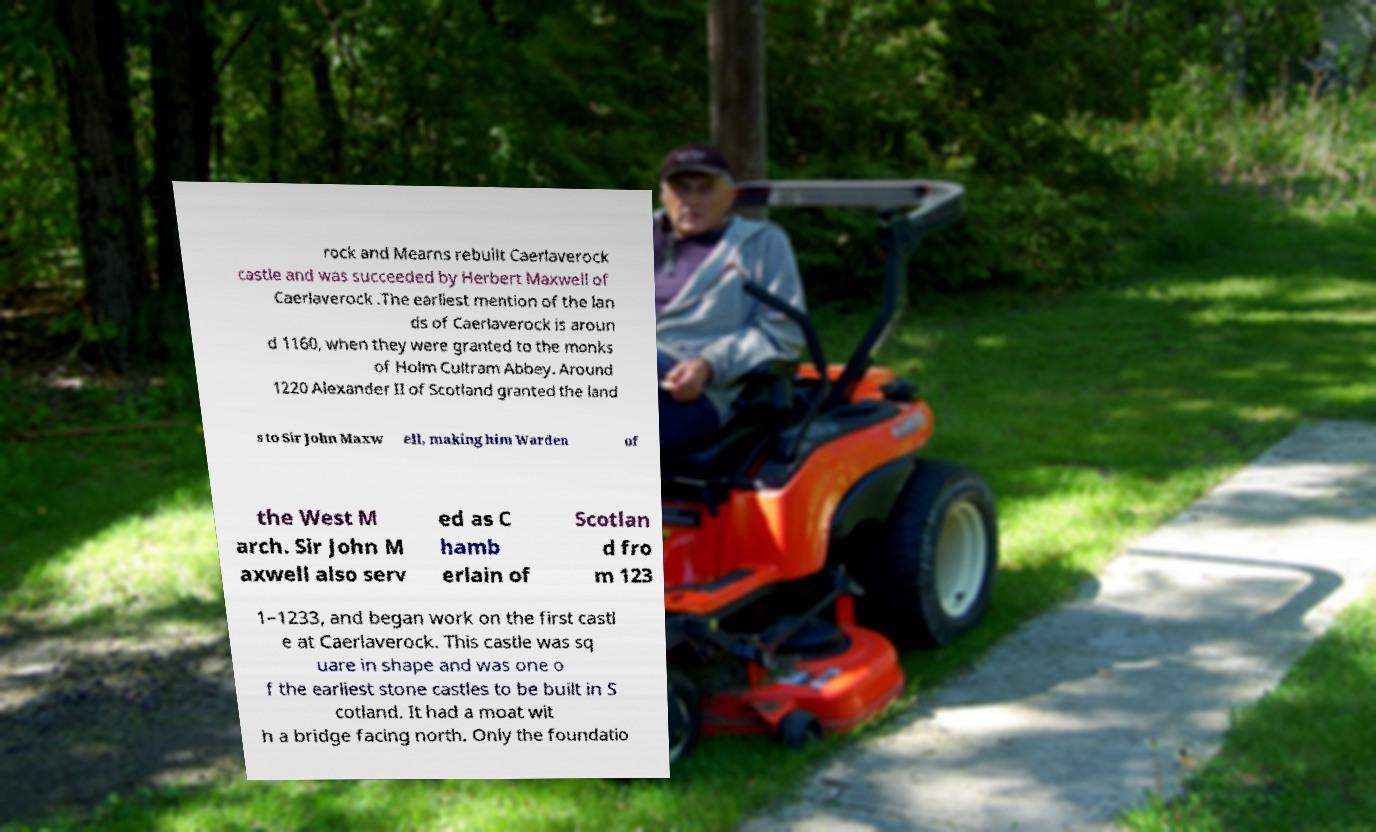There's text embedded in this image that I need extracted. Can you transcribe it verbatim? rock and Mearns rebuilt Caerlaverock castle and was succeeded by Herbert Maxwell of Caerlaverock .The earliest mention of the lan ds of Caerlaverock is aroun d 1160, when they were granted to the monks of Holm Cultram Abbey. Around 1220 Alexander II of Scotland granted the land s to Sir John Maxw ell, making him Warden of the West M arch. Sir John M axwell also serv ed as C hamb erlain of Scotlan d fro m 123 1–1233, and began work on the first castl e at Caerlaverock. This castle was sq uare in shape and was one o f the earliest stone castles to be built in S cotland. It had a moat wit h a bridge facing north. Only the foundatio 